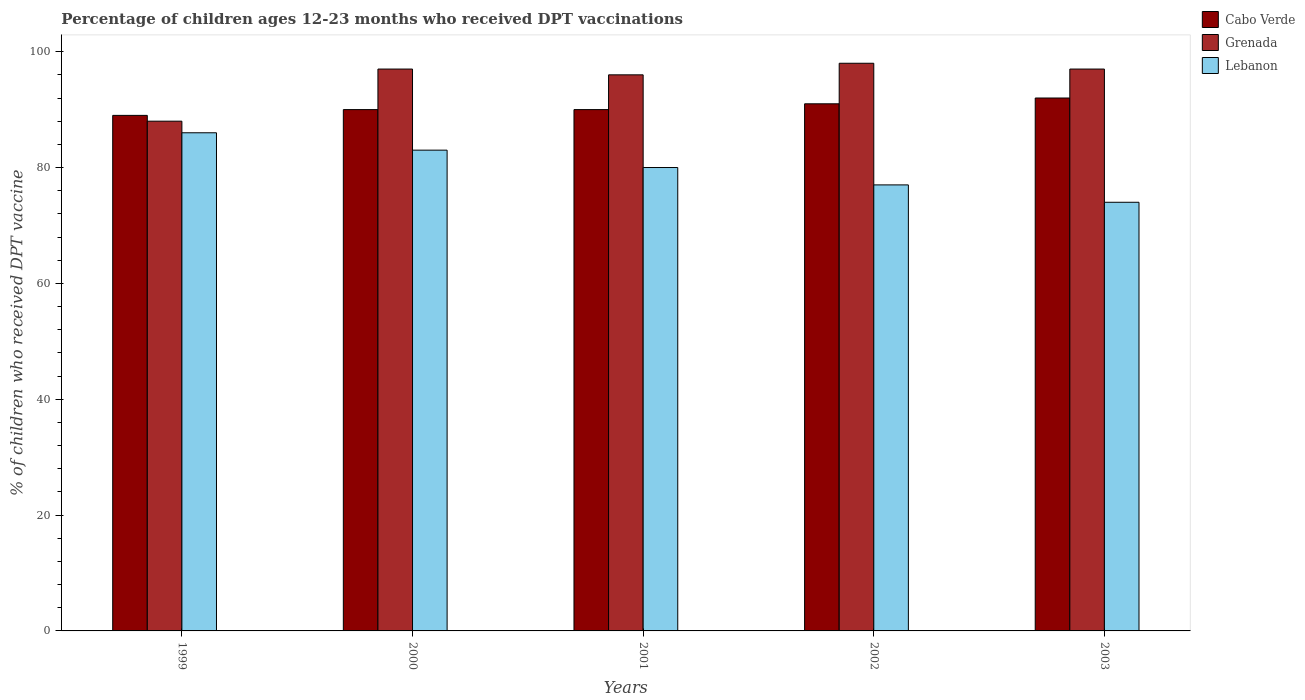How many different coloured bars are there?
Provide a short and direct response. 3. Are the number of bars per tick equal to the number of legend labels?
Your answer should be very brief. Yes. Are the number of bars on each tick of the X-axis equal?
Ensure brevity in your answer.  Yes. How many bars are there on the 3rd tick from the left?
Your answer should be compact. 3. What is the label of the 3rd group of bars from the left?
Offer a very short reply. 2001. In how many cases, is the number of bars for a given year not equal to the number of legend labels?
Offer a terse response. 0. What is the percentage of children who received DPT vaccination in Cabo Verde in 2003?
Make the answer very short. 92. Across all years, what is the maximum percentage of children who received DPT vaccination in Cabo Verde?
Your response must be concise. 92. Across all years, what is the minimum percentage of children who received DPT vaccination in Grenada?
Provide a succinct answer. 88. In which year was the percentage of children who received DPT vaccination in Grenada maximum?
Make the answer very short. 2002. What is the total percentage of children who received DPT vaccination in Cabo Verde in the graph?
Ensure brevity in your answer.  452. What is the difference between the percentage of children who received DPT vaccination in Lebanon in 2001 and that in 2003?
Offer a terse response. 6. What is the average percentage of children who received DPT vaccination in Grenada per year?
Your answer should be very brief. 95.2. In how many years, is the percentage of children who received DPT vaccination in Grenada greater than 4 %?
Give a very brief answer. 5. What is the ratio of the percentage of children who received DPT vaccination in Grenada in 2001 to that in 2003?
Ensure brevity in your answer.  0.99. Is the difference between the percentage of children who received DPT vaccination in Cabo Verde in 1999 and 2002 greater than the difference between the percentage of children who received DPT vaccination in Grenada in 1999 and 2002?
Offer a terse response. Yes. What is the difference between the highest and the second highest percentage of children who received DPT vaccination in Grenada?
Provide a short and direct response. 1. What does the 3rd bar from the left in 2002 represents?
Give a very brief answer. Lebanon. What does the 2nd bar from the right in 2002 represents?
Your answer should be very brief. Grenada. How many years are there in the graph?
Your answer should be compact. 5. Are the values on the major ticks of Y-axis written in scientific E-notation?
Provide a succinct answer. No. How many legend labels are there?
Your answer should be very brief. 3. What is the title of the graph?
Offer a terse response. Percentage of children ages 12-23 months who received DPT vaccinations. Does "Canada" appear as one of the legend labels in the graph?
Your answer should be compact. No. What is the label or title of the X-axis?
Provide a succinct answer. Years. What is the label or title of the Y-axis?
Make the answer very short. % of children who received DPT vaccine. What is the % of children who received DPT vaccine in Cabo Verde in 1999?
Your answer should be compact. 89. What is the % of children who received DPT vaccine of Lebanon in 1999?
Keep it short and to the point. 86. What is the % of children who received DPT vaccine in Cabo Verde in 2000?
Keep it short and to the point. 90. What is the % of children who received DPT vaccine of Grenada in 2000?
Make the answer very short. 97. What is the % of children who received DPT vaccine of Cabo Verde in 2001?
Keep it short and to the point. 90. What is the % of children who received DPT vaccine of Grenada in 2001?
Provide a short and direct response. 96. What is the % of children who received DPT vaccine in Lebanon in 2001?
Provide a short and direct response. 80. What is the % of children who received DPT vaccine of Cabo Verde in 2002?
Ensure brevity in your answer.  91. What is the % of children who received DPT vaccine in Grenada in 2002?
Your answer should be compact. 98. What is the % of children who received DPT vaccine of Lebanon in 2002?
Ensure brevity in your answer.  77. What is the % of children who received DPT vaccine of Cabo Verde in 2003?
Provide a short and direct response. 92. What is the % of children who received DPT vaccine of Grenada in 2003?
Provide a succinct answer. 97. What is the % of children who received DPT vaccine of Lebanon in 2003?
Provide a short and direct response. 74. Across all years, what is the maximum % of children who received DPT vaccine in Cabo Verde?
Provide a short and direct response. 92. Across all years, what is the maximum % of children who received DPT vaccine of Lebanon?
Give a very brief answer. 86. Across all years, what is the minimum % of children who received DPT vaccine in Cabo Verde?
Offer a terse response. 89. Across all years, what is the minimum % of children who received DPT vaccine of Grenada?
Ensure brevity in your answer.  88. Across all years, what is the minimum % of children who received DPT vaccine of Lebanon?
Your answer should be very brief. 74. What is the total % of children who received DPT vaccine of Cabo Verde in the graph?
Offer a terse response. 452. What is the total % of children who received DPT vaccine in Grenada in the graph?
Offer a terse response. 476. What is the difference between the % of children who received DPT vaccine in Lebanon in 1999 and that in 2000?
Your answer should be compact. 3. What is the difference between the % of children who received DPT vaccine in Cabo Verde in 1999 and that in 2001?
Your answer should be very brief. -1. What is the difference between the % of children who received DPT vaccine of Lebanon in 1999 and that in 2001?
Provide a short and direct response. 6. What is the difference between the % of children who received DPT vaccine of Cabo Verde in 1999 and that in 2002?
Keep it short and to the point. -2. What is the difference between the % of children who received DPT vaccine in Grenada in 1999 and that in 2002?
Your response must be concise. -10. What is the difference between the % of children who received DPT vaccine in Lebanon in 1999 and that in 2002?
Provide a short and direct response. 9. What is the difference between the % of children who received DPT vaccine of Lebanon in 1999 and that in 2003?
Ensure brevity in your answer.  12. What is the difference between the % of children who received DPT vaccine in Cabo Verde in 2000 and that in 2001?
Keep it short and to the point. 0. What is the difference between the % of children who received DPT vaccine of Grenada in 2000 and that in 2001?
Your response must be concise. 1. What is the difference between the % of children who received DPT vaccine of Lebanon in 2000 and that in 2001?
Keep it short and to the point. 3. What is the difference between the % of children who received DPT vaccine of Cabo Verde in 2000 and that in 2002?
Ensure brevity in your answer.  -1. What is the difference between the % of children who received DPT vaccine of Grenada in 2000 and that in 2002?
Ensure brevity in your answer.  -1. What is the difference between the % of children who received DPT vaccine in Lebanon in 2000 and that in 2002?
Ensure brevity in your answer.  6. What is the difference between the % of children who received DPT vaccine in Grenada in 2000 and that in 2003?
Provide a short and direct response. 0. What is the difference between the % of children who received DPT vaccine of Lebanon in 2001 and that in 2002?
Make the answer very short. 3. What is the difference between the % of children who received DPT vaccine in Cabo Verde in 2002 and that in 2003?
Keep it short and to the point. -1. What is the difference between the % of children who received DPT vaccine in Cabo Verde in 1999 and the % of children who received DPT vaccine in Lebanon in 2000?
Give a very brief answer. 6. What is the difference between the % of children who received DPT vaccine in Grenada in 1999 and the % of children who received DPT vaccine in Lebanon in 2001?
Offer a very short reply. 8. What is the difference between the % of children who received DPT vaccine of Cabo Verde in 1999 and the % of children who received DPT vaccine of Lebanon in 2002?
Keep it short and to the point. 12. What is the difference between the % of children who received DPT vaccine in Grenada in 1999 and the % of children who received DPT vaccine in Lebanon in 2002?
Offer a very short reply. 11. What is the difference between the % of children who received DPT vaccine of Cabo Verde in 1999 and the % of children who received DPT vaccine of Grenada in 2003?
Ensure brevity in your answer.  -8. What is the difference between the % of children who received DPT vaccine in Cabo Verde in 1999 and the % of children who received DPT vaccine in Lebanon in 2003?
Offer a terse response. 15. What is the difference between the % of children who received DPT vaccine in Grenada in 1999 and the % of children who received DPT vaccine in Lebanon in 2003?
Offer a terse response. 14. What is the difference between the % of children who received DPT vaccine in Cabo Verde in 2000 and the % of children who received DPT vaccine in Lebanon in 2001?
Offer a terse response. 10. What is the difference between the % of children who received DPT vaccine in Grenada in 2000 and the % of children who received DPT vaccine in Lebanon in 2001?
Provide a short and direct response. 17. What is the difference between the % of children who received DPT vaccine of Cabo Verde in 2000 and the % of children who received DPT vaccine of Grenada in 2002?
Ensure brevity in your answer.  -8. What is the difference between the % of children who received DPT vaccine in Cabo Verde in 2000 and the % of children who received DPT vaccine in Lebanon in 2002?
Your answer should be compact. 13. What is the difference between the % of children who received DPT vaccine of Cabo Verde in 2000 and the % of children who received DPT vaccine of Lebanon in 2003?
Offer a very short reply. 16. What is the difference between the % of children who received DPT vaccine in Grenada in 2000 and the % of children who received DPT vaccine in Lebanon in 2003?
Provide a short and direct response. 23. What is the difference between the % of children who received DPT vaccine of Cabo Verde in 2001 and the % of children who received DPT vaccine of Lebanon in 2002?
Ensure brevity in your answer.  13. What is the difference between the % of children who received DPT vaccine of Cabo Verde in 2002 and the % of children who received DPT vaccine of Lebanon in 2003?
Your answer should be compact. 17. What is the average % of children who received DPT vaccine of Cabo Verde per year?
Provide a short and direct response. 90.4. What is the average % of children who received DPT vaccine in Grenada per year?
Make the answer very short. 95.2. In the year 1999, what is the difference between the % of children who received DPT vaccine of Cabo Verde and % of children who received DPT vaccine of Grenada?
Give a very brief answer. 1. In the year 1999, what is the difference between the % of children who received DPT vaccine in Cabo Verde and % of children who received DPT vaccine in Lebanon?
Your response must be concise. 3. In the year 1999, what is the difference between the % of children who received DPT vaccine in Grenada and % of children who received DPT vaccine in Lebanon?
Offer a very short reply. 2. In the year 2001, what is the difference between the % of children who received DPT vaccine in Cabo Verde and % of children who received DPT vaccine in Lebanon?
Offer a very short reply. 10. In the year 2002, what is the difference between the % of children who received DPT vaccine in Cabo Verde and % of children who received DPT vaccine in Grenada?
Provide a succinct answer. -7. In the year 2002, what is the difference between the % of children who received DPT vaccine in Grenada and % of children who received DPT vaccine in Lebanon?
Offer a very short reply. 21. In the year 2003, what is the difference between the % of children who received DPT vaccine of Grenada and % of children who received DPT vaccine of Lebanon?
Keep it short and to the point. 23. What is the ratio of the % of children who received DPT vaccine in Cabo Verde in 1999 to that in 2000?
Your answer should be very brief. 0.99. What is the ratio of the % of children who received DPT vaccine of Grenada in 1999 to that in 2000?
Offer a very short reply. 0.91. What is the ratio of the % of children who received DPT vaccine of Lebanon in 1999 to that in 2000?
Your answer should be compact. 1.04. What is the ratio of the % of children who received DPT vaccine in Cabo Verde in 1999 to that in 2001?
Provide a short and direct response. 0.99. What is the ratio of the % of children who received DPT vaccine in Lebanon in 1999 to that in 2001?
Your answer should be very brief. 1.07. What is the ratio of the % of children who received DPT vaccine of Cabo Verde in 1999 to that in 2002?
Your response must be concise. 0.98. What is the ratio of the % of children who received DPT vaccine of Grenada in 1999 to that in 2002?
Keep it short and to the point. 0.9. What is the ratio of the % of children who received DPT vaccine in Lebanon in 1999 to that in 2002?
Your answer should be very brief. 1.12. What is the ratio of the % of children who received DPT vaccine of Cabo Verde in 1999 to that in 2003?
Your answer should be compact. 0.97. What is the ratio of the % of children who received DPT vaccine in Grenada in 1999 to that in 2003?
Provide a short and direct response. 0.91. What is the ratio of the % of children who received DPT vaccine of Lebanon in 1999 to that in 2003?
Offer a terse response. 1.16. What is the ratio of the % of children who received DPT vaccine of Grenada in 2000 to that in 2001?
Give a very brief answer. 1.01. What is the ratio of the % of children who received DPT vaccine in Lebanon in 2000 to that in 2001?
Ensure brevity in your answer.  1.04. What is the ratio of the % of children who received DPT vaccine of Lebanon in 2000 to that in 2002?
Your answer should be very brief. 1.08. What is the ratio of the % of children who received DPT vaccine in Cabo Verde in 2000 to that in 2003?
Make the answer very short. 0.98. What is the ratio of the % of children who received DPT vaccine in Lebanon in 2000 to that in 2003?
Keep it short and to the point. 1.12. What is the ratio of the % of children who received DPT vaccine of Grenada in 2001 to that in 2002?
Your answer should be very brief. 0.98. What is the ratio of the % of children who received DPT vaccine of Lebanon in 2001 to that in 2002?
Your response must be concise. 1.04. What is the ratio of the % of children who received DPT vaccine of Cabo Verde in 2001 to that in 2003?
Make the answer very short. 0.98. What is the ratio of the % of children who received DPT vaccine in Grenada in 2001 to that in 2003?
Give a very brief answer. 0.99. What is the ratio of the % of children who received DPT vaccine of Lebanon in 2001 to that in 2003?
Your response must be concise. 1.08. What is the ratio of the % of children who received DPT vaccine in Grenada in 2002 to that in 2003?
Keep it short and to the point. 1.01. What is the ratio of the % of children who received DPT vaccine in Lebanon in 2002 to that in 2003?
Provide a succinct answer. 1.04. What is the difference between the highest and the second highest % of children who received DPT vaccine in Grenada?
Your answer should be compact. 1. What is the difference between the highest and the lowest % of children who received DPT vaccine of Grenada?
Your answer should be very brief. 10. What is the difference between the highest and the lowest % of children who received DPT vaccine of Lebanon?
Ensure brevity in your answer.  12. 